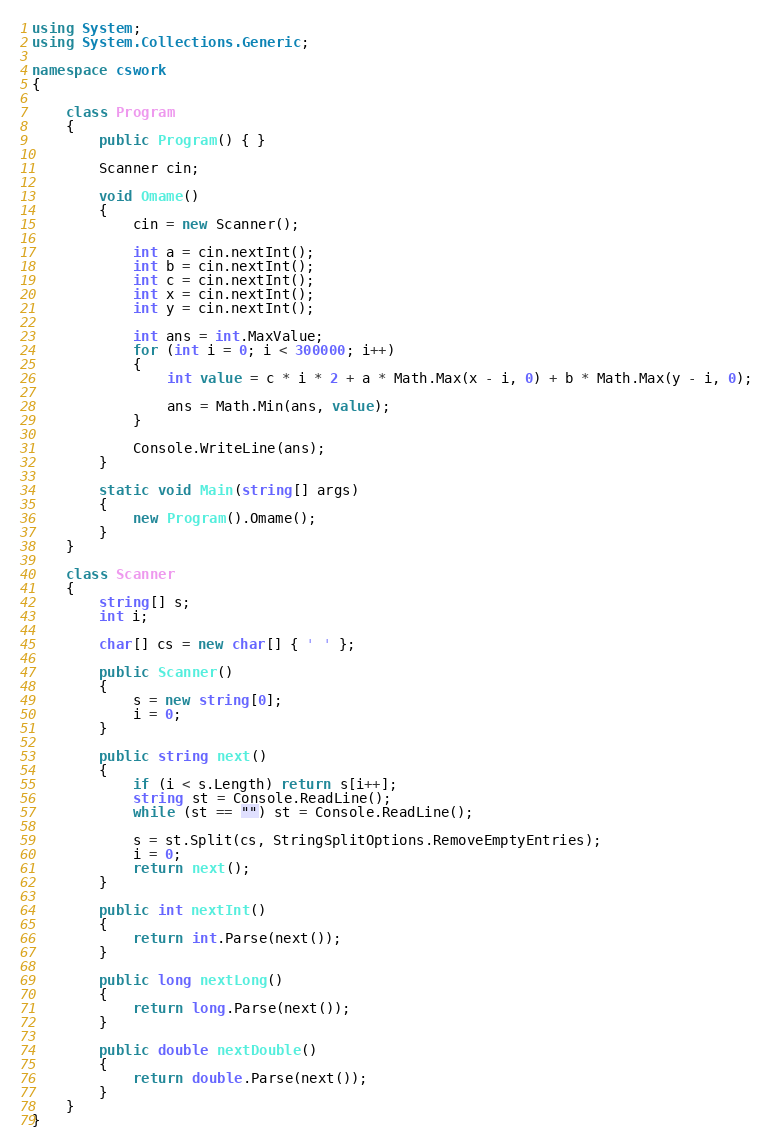Convert code to text. <code><loc_0><loc_0><loc_500><loc_500><_C#_>using System;
using System.Collections.Generic;

namespace cswork
{

    class Program
    {
        public Program() { }

        Scanner cin;

        void Omame()
        {
            cin = new Scanner();

            int a = cin.nextInt();
            int b = cin.nextInt();
            int c = cin.nextInt();
            int x = cin.nextInt();
            int y = cin.nextInt();

            int ans = int.MaxValue;
            for (int i = 0; i < 300000; i++)
            {
                int value = c * i * 2 + a * Math.Max(x - i, 0) + b * Math.Max(y - i, 0);

                ans = Math.Min(ans, value);
            }

            Console.WriteLine(ans);
        }

        static void Main(string[] args)
        {
            new Program().Omame();
        }
    }

    class Scanner
    {
        string[] s;
        int i;

        char[] cs = new char[] { ' ' };

        public Scanner()
        {
            s = new string[0];
            i = 0;
        }

        public string next()
        {
            if (i < s.Length) return s[i++];
            string st = Console.ReadLine();
            while (st == "") st = Console.ReadLine();

            s = st.Split(cs, StringSplitOptions.RemoveEmptyEntries);
            i = 0;
            return next();
        }

        public int nextInt()
        {
            return int.Parse(next());
        }

        public long nextLong()
        {
            return long.Parse(next());
        }

        public double nextDouble()
        {
            return double.Parse(next());
        }
    }
}</code> 